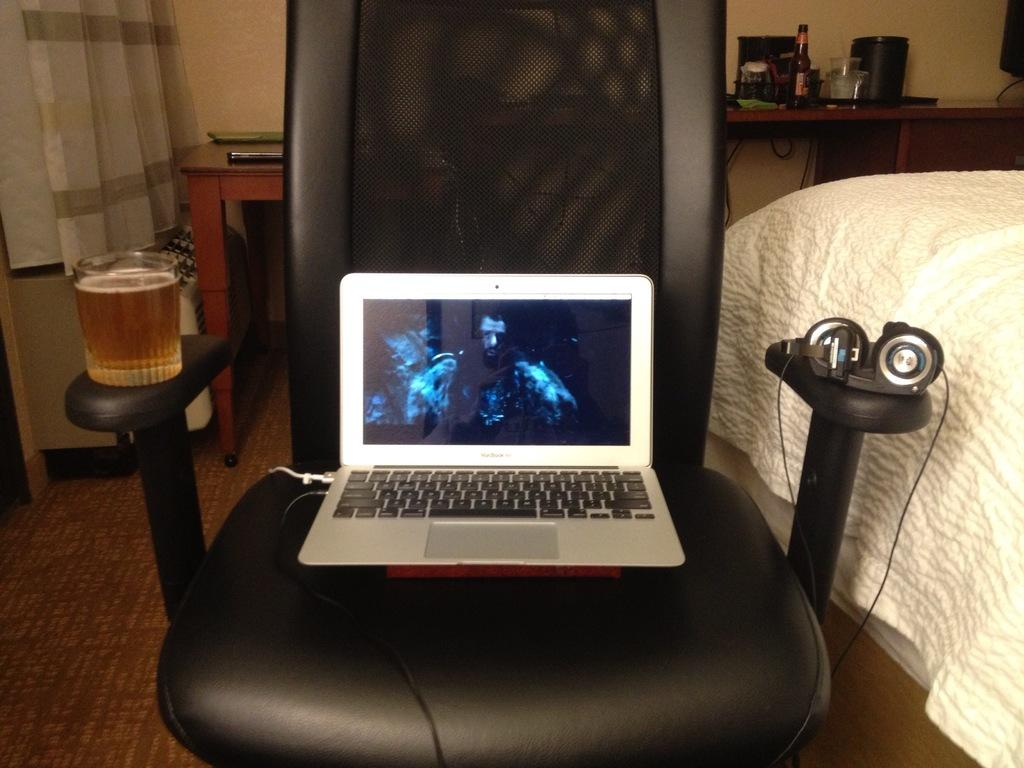What electronic device is visible in the image? There is a laptop in the image. What is used for listening to audio in the image? There are headphones in the image. What type of glassware is present in the image? There is a wineglass in the image. Where is the wineglass located in the image? The wineglass is on a chair. What is on the right side of the image? There is a bed on the right side of the image. What type of container is present in the image? There is a bottle in the image. What type of object is box-shaped in the image? There is a box in the image. What type of manager is sitting on the bed in the image? There is no manager present in the image; it only shows a laptop, headphones, a wineglass, a chair, a bed, a bottle, and a box. What type of metal is used to make the attention-grabbing object in the image? There is no attention-grabbing object made of metal present in the image. 